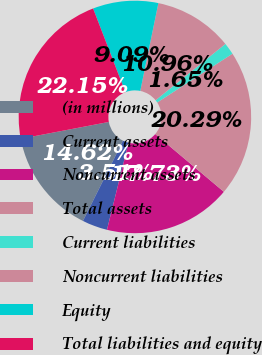Convert chart. <chart><loc_0><loc_0><loc_500><loc_500><pie_chart><fcel>(in millions)<fcel>Current assets<fcel>Noncurrent assets<fcel>Total assets<fcel>Current liabilities<fcel>Noncurrent liabilities<fcel>Equity<fcel>Total liabilities and equity<nl><fcel>14.62%<fcel>3.51%<fcel>17.73%<fcel>20.29%<fcel>1.65%<fcel>10.96%<fcel>9.09%<fcel>22.15%<nl></chart> 